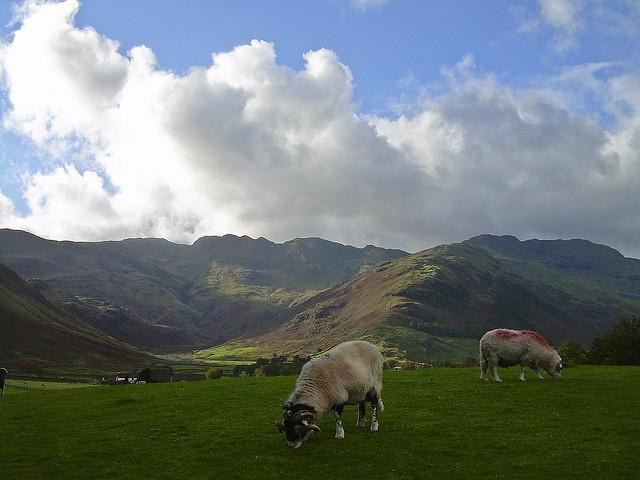How many sheep are there?
Give a very brief answer. 2. 